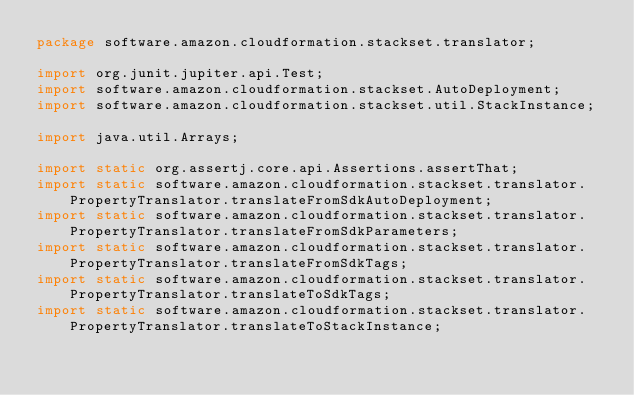Convert code to text. <code><loc_0><loc_0><loc_500><loc_500><_Java_>package software.amazon.cloudformation.stackset.translator;

import org.junit.jupiter.api.Test;
import software.amazon.cloudformation.stackset.AutoDeployment;
import software.amazon.cloudformation.stackset.util.StackInstance;

import java.util.Arrays;

import static org.assertj.core.api.Assertions.assertThat;
import static software.amazon.cloudformation.stackset.translator.PropertyTranslator.translateFromSdkAutoDeployment;
import static software.amazon.cloudformation.stackset.translator.PropertyTranslator.translateFromSdkParameters;
import static software.amazon.cloudformation.stackset.translator.PropertyTranslator.translateFromSdkTags;
import static software.amazon.cloudformation.stackset.translator.PropertyTranslator.translateToSdkTags;
import static software.amazon.cloudformation.stackset.translator.PropertyTranslator.translateToStackInstance;</code> 